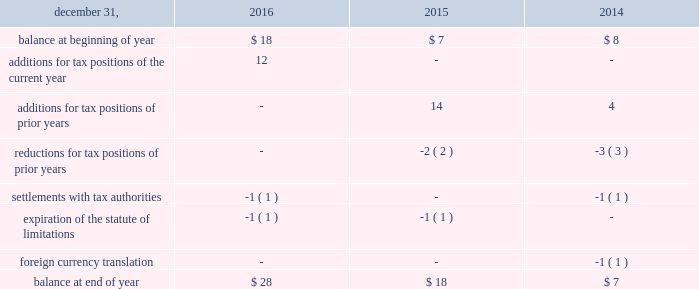Arconic and its subsidiaries file income tax returns in the u.s .
Federal jurisdiction and various states and foreign jurisdictions .
With a few minor exceptions , arconic is no longer subject to income tax examinations by tax authorities for years prior to 2006 .
All u.s .
Tax years prior to 2016 have been audited by the internal revenue service .
Various state and foreign jurisdiction tax authorities are in the process of examining arconic 2019s income tax returns for various tax years through 2015 .
A reconciliation of the beginning and ending amount of unrecognized tax benefits ( excluding interest and penalties ) was as follows: .
For all periods presented , a portion of the balance at end of year pertains to state tax liabilities , which are presented before any offset for federal tax benefits .
The effect of unrecognized tax benefits , if recorded , that would impact the annual effective tax rate for 2016 , 2015 , and 2014 would be approximately 6% ( 6 % ) , 7% ( 7 % ) , and 4% ( 4 % ) , respectively , of pretax book income .
Arconic does not anticipate that changes in its unrecognized tax benefits will have a material impact on the statement of consolidated operations during 2017 ( see tax in note l for a matter for which no reserve has been recognized ) .
It is arconic 2019s policy to recognize interest and penalties related to income taxes as a component of the provision for income taxes on the accompanying statement of consolidated operations .
In 2016 , 2015 , and 2014 , arconic did not recognize any interest or penalties .
Due to the expiration of the statute of limitations , settlements with tax authorities , and refunded overpayments , arconic recognized interest income of $ 1 in 2015 but did not recognize any interest income in 2016 or 2014 .
As of december 31 , 2016 and 2015 , the amount accrued for the payment of interest and penalties was $ 2 and $ 1 , respectively .
Receivables sale of receivables programs arconic has an arrangement with three financial institutions to sell certain customer receivables without recourse on a revolving basis .
The sale of such receivables is completed through the use of a bankruptcy remote special purpose entity , which is a consolidated subsidiary of arconic .
This arrangement provides for minimum funding of $ 200 up to a maximum of $ 400 for receivables sold .
On march 30 , 2012 , arconic initially sold $ 304 of customer receivables in exchange for $ 50 in cash and $ 254 of deferred purchase price under this arrangement .
Arconic has received additional net cash funding of $ 300 for receivables sold ( $ 1758 in draws and $ 1458 in repayments ) since the program 2019s inception , including $ 100 ( $ 500 in draws and $ 400 in repayments ) in 2016 .
No draws or repayments occurred in 2015 .
As of december 31 , 2016 and 2015 , the deferred purchase price receivable was $ 83 and $ 249 , respectively , which was included in other receivables on the accompanying consolidated balance sheet .
The deferred purchase price receivable is reduced as collections of the underlying receivables occur ; however , as this is a revolving program , the sale of new receivables will result in an increase in the deferred purchase price receivable .
The net change in the deferred purchase price receivable was reflected in the ( increase ) decrease in receivables line item on the accompanying statement of consolidated cash flows .
This activity is reflected as an operating cash flow because the related customer receivables are the result of an operating activity with an insignificant , short-term interest rate risk. .
What was the decrease observed in the deferred purchase price receivable during 2015 and 2016? 
Rationale: it is the percentual variation between the deferred purchase price receivable in 2016 and 2015 , that is calculated by subtracting the final value of the initial value then dividing and turning it into a percentage .
Computations: ((83 - 249) / 249)
Answer: -0.66667. 